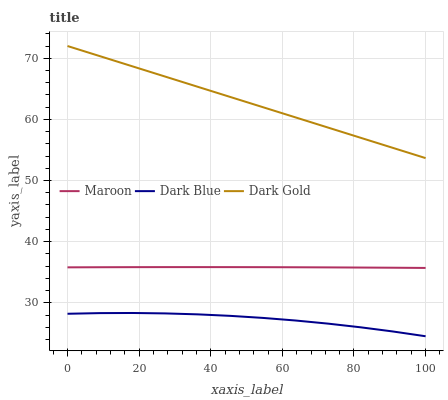Does Dark Blue have the minimum area under the curve?
Answer yes or no. Yes. Does Dark Gold have the maximum area under the curve?
Answer yes or no. Yes. Does Maroon have the minimum area under the curve?
Answer yes or no. No. Does Maroon have the maximum area under the curve?
Answer yes or no. No. Is Dark Gold the smoothest?
Answer yes or no. Yes. Is Dark Blue the roughest?
Answer yes or no. Yes. Is Maroon the smoothest?
Answer yes or no. No. Is Maroon the roughest?
Answer yes or no. No. Does Dark Blue have the lowest value?
Answer yes or no. Yes. Does Maroon have the lowest value?
Answer yes or no. No. Does Dark Gold have the highest value?
Answer yes or no. Yes. Does Maroon have the highest value?
Answer yes or no. No. Is Maroon less than Dark Gold?
Answer yes or no. Yes. Is Dark Gold greater than Maroon?
Answer yes or no. Yes. Does Maroon intersect Dark Gold?
Answer yes or no. No. 